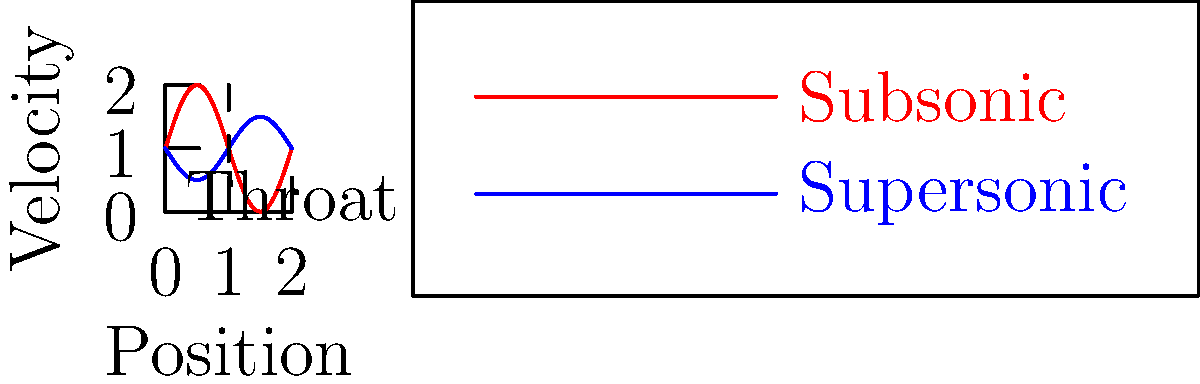In the context of a converging-diverging nozzle, how does the velocity profile of air change as it passes through the nozzle, and what musical analogy might you draw to explain this phenomenon to your opera students? To explain the velocity profile of air flowing through a converging-diverging nozzle, let's break it down step-by-step:

1. Entrance region (converging section):
   - As air enters the converging section, its velocity increases gradually.
   - This is similar to how a singer's breath accelerates as it passes through the narrowing vocal tract.

2. Throat:
   - The air reaches its maximum subsonic velocity at the throat (narrowest point).
   - This can be likened to the moment just before a high note, where the vocal folds are most tense.

3. Diverging section:
   - After the throat, the nozzle expands, and the air's behavior depends on the pressure ratio:

   a) Subsonic flow (red line):
      - If the pressure ratio is below critical, the air decelerates.
      - This is analogous to how a singer's voice "spreads" in a large concert hall.

   b) Supersonic flow (blue line):
      - If the pressure ratio is above critical, the air continues to accelerate.
      - This can be compared to how a singer's voice carries further in an outdoor amphitheater.

4. Musical analogy:
   - The nozzle shape is like the vocal tract, modulating air flow.
   - The throat represents the vocal folds at their most constricted.
   - The diverging section is similar to how sound waves expand in space after leaving the mouth.

The velocity profile's shape depends on whether the flow becomes supersonic (blue line) or remains subsonic (red line) after the throat, which is determined by the pressure ratio across the nozzle.
Answer: Velocity increases in converging section, reaches maximum at throat, then either decreases (subsonic) or increases (supersonic) in diverging section, analogous to air flow in singing. 